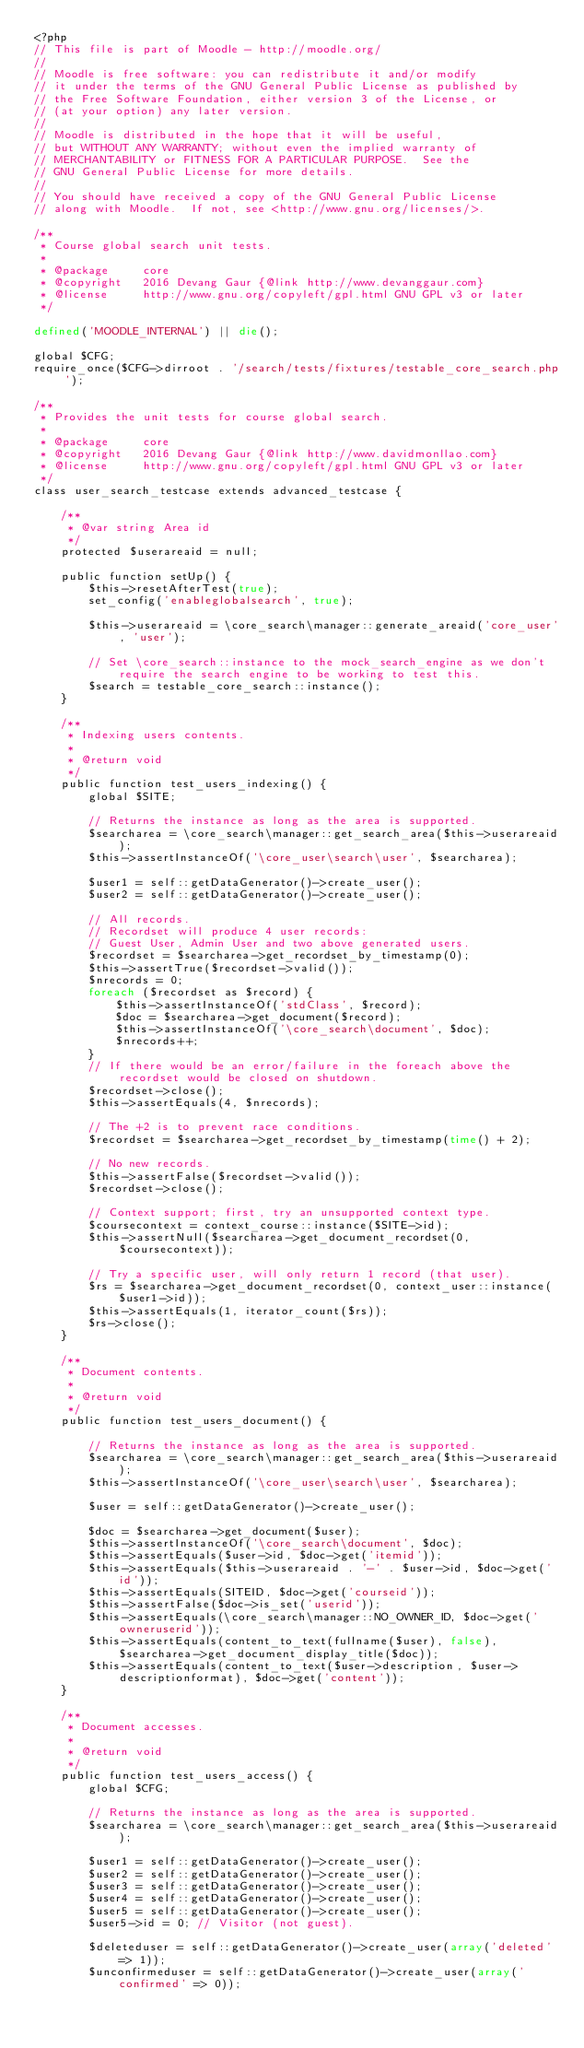<code> <loc_0><loc_0><loc_500><loc_500><_PHP_><?php
// This file is part of Moodle - http://moodle.org/
//
// Moodle is free software: you can redistribute it and/or modify
// it under the terms of the GNU General Public License as published by
// the Free Software Foundation, either version 3 of the License, or
// (at your option) any later version.
//
// Moodle is distributed in the hope that it will be useful,
// but WITHOUT ANY WARRANTY; without even the implied warranty of
// MERCHANTABILITY or FITNESS FOR A PARTICULAR PURPOSE.  See the
// GNU General Public License for more details.
//
// You should have received a copy of the GNU General Public License
// along with Moodle.  If not, see <http://www.gnu.org/licenses/>.

/**
 * Course global search unit tests.
 *
 * @package     core
 * @copyright   2016 Devang Gaur {@link http://www.devanggaur.com}
 * @license     http://www.gnu.org/copyleft/gpl.html GNU GPL v3 or later
 */

defined('MOODLE_INTERNAL') || die();

global $CFG;
require_once($CFG->dirroot . '/search/tests/fixtures/testable_core_search.php');

/**
 * Provides the unit tests for course global search.
 *
 * @package     core
 * @copyright   2016 Devang Gaur {@link http://www.davidmonllao.com}
 * @license     http://www.gnu.org/copyleft/gpl.html GNU GPL v3 or later
 */
class user_search_testcase extends advanced_testcase {

    /**
     * @var string Area id
     */
    protected $userareaid = null;

    public function setUp() {
        $this->resetAfterTest(true);
        set_config('enableglobalsearch', true);

        $this->userareaid = \core_search\manager::generate_areaid('core_user', 'user');

        // Set \core_search::instance to the mock_search_engine as we don't require the search engine to be working to test this.
        $search = testable_core_search::instance();
    }

    /**
     * Indexing users contents.
     *
     * @return void
     */
    public function test_users_indexing() {
        global $SITE;

        // Returns the instance as long as the area is supported.
        $searcharea = \core_search\manager::get_search_area($this->userareaid);
        $this->assertInstanceOf('\core_user\search\user', $searcharea);

        $user1 = self::getDataGenerator()->create_user();
        $user2 = self::getDataGenerator()->create_user();

        // All records.
        // Recordset will produce 4 user records:
        // Guest User, Admin User and two above generated users.
        $recordset = $searcharea->get_recordset_by_timestamp(0);
        $this->assertTrue($recordset->valid());
        $nrecords = 0;
        foreach ($recordset as $record) {
            $this->assertInstanceOf('stdClass', $record);
            $doc = $searcharea->get_document($record);
            $this->assertInstanceOf('\core_search\document', $doc);
            $nrecords++;
        }
        // If there would be an error/failure in the foreach above the recordset would be closed on shutdown.
        $recordset->close();
        $this->assertEquals(4, $nrecords);

        // The +2 is to prevent race conditions.
        $recordset = $searcharea->get_recordset_by_timestamp(time() + 2);

        // No new records.
        $this->assertFalse($recordset->valid());
        $recordset->close();

        // Context support; first, try an unsupported context type.
        $coursecontext = context_course::instance($SITE->id);
        $this->assertNull($searcharea->get_document_recordset(0, $coursecontext));

        // Try a specific user, will only return 1 record (that user).
        $rs = $searcharea->get_document_recordset(0, context_user::instance($user1->id));
        $this->assertEquals(1, iterator_count($rs));
        $rs->close();
    }

    /**
     * Document contents.
     *
     * @return void
     */
    public function test_users_document() {

        // Returns the instance as long as the area is supported.
        $searcharea = \core_search\manager::get_search_area($this->userareaid);
        $this->assertInstanceOf('\core_user\search\user', $searcharea);

        $user = self::getDataGenerator()->create_user();

        $doc = $searcharea->get_document($user);
        $this->assertInstanceOf('\core_search\document', $doc);
        $this->assertEquals($user->id, $doc->get('itemid'));
        $this->assertEquals($this->userareaid . '-' . $user->id, $doc->get('id'));
        $this->assertEquals(SITEID, $doc->get('courseid'));
        $this->assertFalse($doc->is_set('userid'));
        $this->assertEquals(\core_search\manager::NO_OWNER_ID, $doc->get('owneruserid'));
        $this->assertEquals(content_to_text(fullname($user), false), $searcharea->get_document_display_title($doc));
        $this->assertEquals(content_to_text($user->description, $user->descriptionformat), $doc->get('content'));
    }

    /**
     * Document accesses.
     *
     * @return void
     */
    public function test_users_access() {
        global $CFG;

        // Returns the instance as long as the area is supported.
        $searcharea = \core_search\manager::get_search_area($this->userareaid);

        $user1 = self::getDataGenerator()->create_user();
        $user2 = self::getDataGenerator()->create_user();
        $user3 = self::getDataGenerator()->create_user();
        $user4 = self::getDataGenerator()->create_user();
        $user5 = self::getDataGenerator()->create_user();
        $user5->id = 0; // Visitor (not guest).

        $deleteduser = self::getDataGenerator()->create_user(array('deleted' => 1));
        $unconfirmeduser = self::getDataGenerator()->create_user(array('confirmed' => 0));</code> 